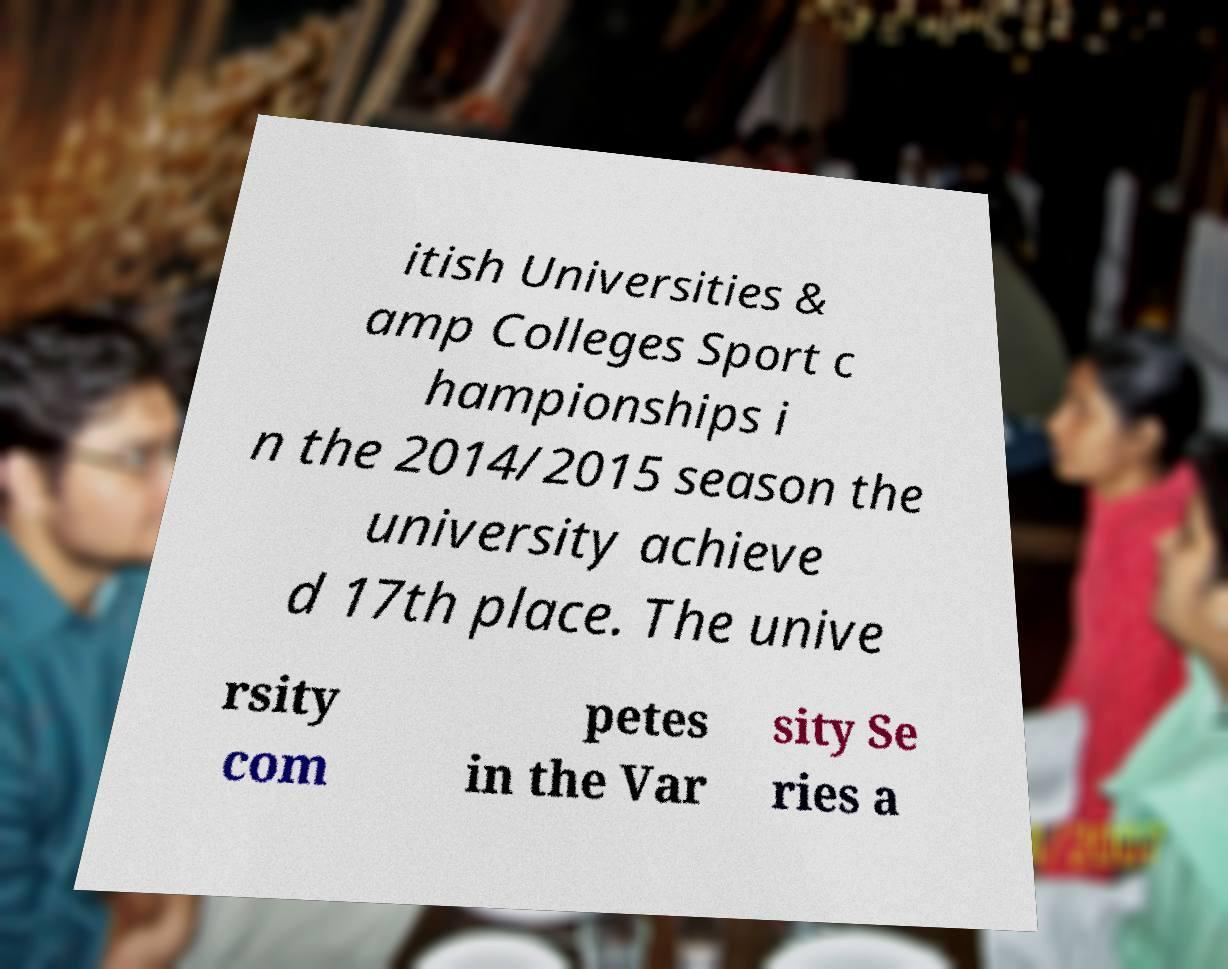I need the written content from this picture converted into text. Can you do that? itish Universities & amp Colleges Sport c hampionships i n the 2014/2015 season the university achieve d 17th place. The unive rsity com petes in the Var sity Se ries a 